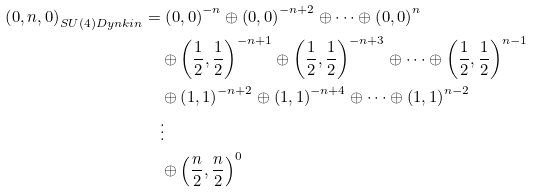Convert formula to latex. <formula><loc_0><loc_0><loc_500><loc_500>\left ( 0 , n , 0 \right ) _ { S U ( 4 ) D y n k i n } & = \left ( 0 , 0 \right ) ^ { - n } \oplus \left ( 0 , 0 \right ) ^ { - n + 2 } \oplus \dots \oplus \left ( 0 , 0 \right ) ^ { n } \\ & \quad \oplus \left ( \frac { 1 } { 2 } , \frac { 1 } { 2 } \right ) ^ { - n + 1 } \oplus \left ( \frac { 1 } { 2 } , \frac { 1 } { 2 } \right ) ^ { - n + 3 } \oplus \dots \oplus \left ( \frac { 1 } { 2 } , \frac { 1 } { 2 } \right ) ^ { n - 1 } \\ & \quad \oplus \left ( 1 , 1 \right ) ^ { - n + 2 } \oplus \left ( 1 , 1 \right ) ^ { - n + 4 } \oplus \dots \oplus \left ( 1 , 1 \right ) ^ { n - 2 } \\ & \quad \vdots \\ & \quad \oplus \left ( \frac { n } { 2 } , \frac { n } { 2 } \right ) ^ { 0 }</formula> 